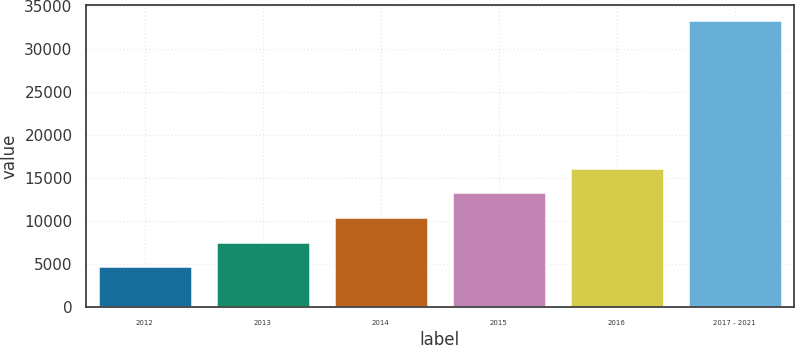<chart> <loc_0><loc_0><loc_500><loc_500><bar_chart><fcel>2012<fcel>2013<fcel>2014<fcel>2015<fcel>2016<fcel>2017 - 2021<nl><fcel>4708<fcel>7576.6<fcel>10445.2<fcel>13313.8<fcel>16182.4<fcel>33394<nl></chart> 